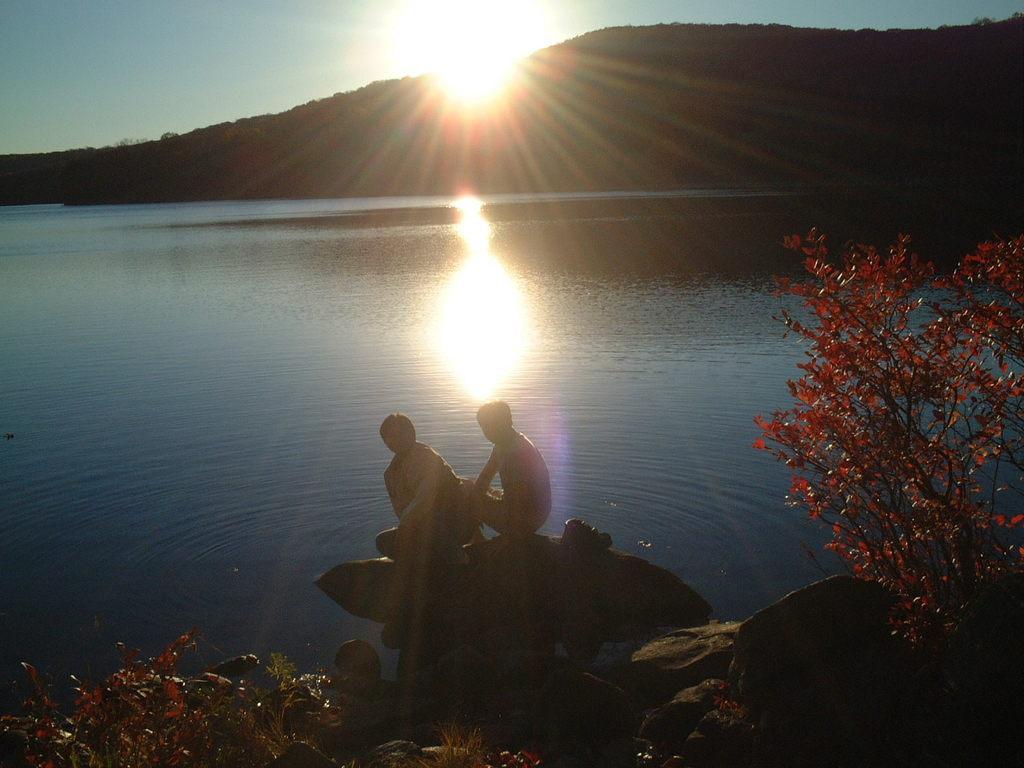Describe this image in one or two sentences. In this image there are two persons sitting on a stone, on the left side and right side there are plants, in the background there is a river mountain and rising sun in the sky. 